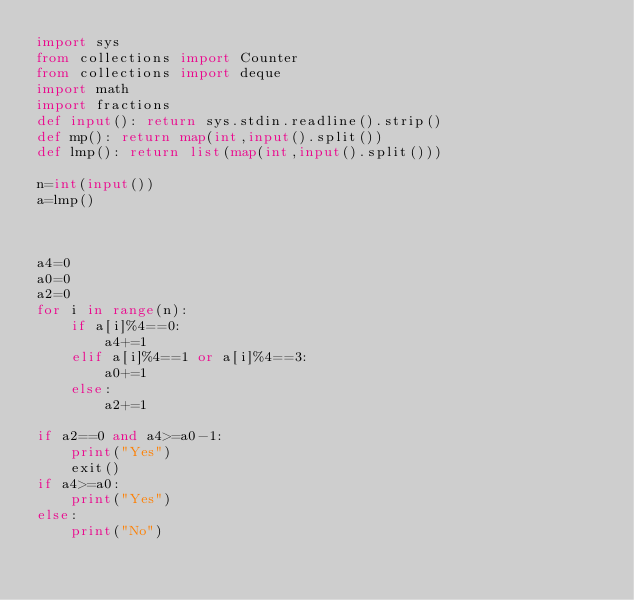Convert code to text. <code><loc_0><loc_0><loc_500><loc_500><_Python_>import sys
from collections import Counter
from collections import deque
import math
import fractions
def input(): return sys.stdin.readline().strip()
def mp(): return map(int,input().split())
def lmp(): return list(map(int,input().split()))

n=int(input())
a=lmp()



a4=0
a0=0
a2=0
for i in range(n):
    if a[i]%4==0:
        a4+=1
    elif a[i]%4==1 or a[i]%4==3:
        a0+=1
    else:
        a2+=1

if a2==0 and a4>=a0-1:
    print("Yes")
    exit()
if a4>=a0:
    print("Yes")
else:
    print("No")</code> 